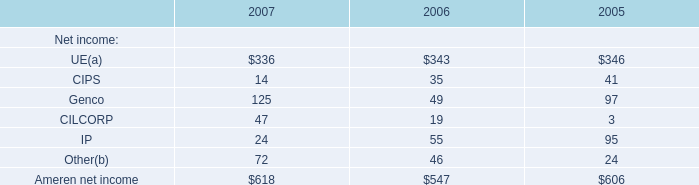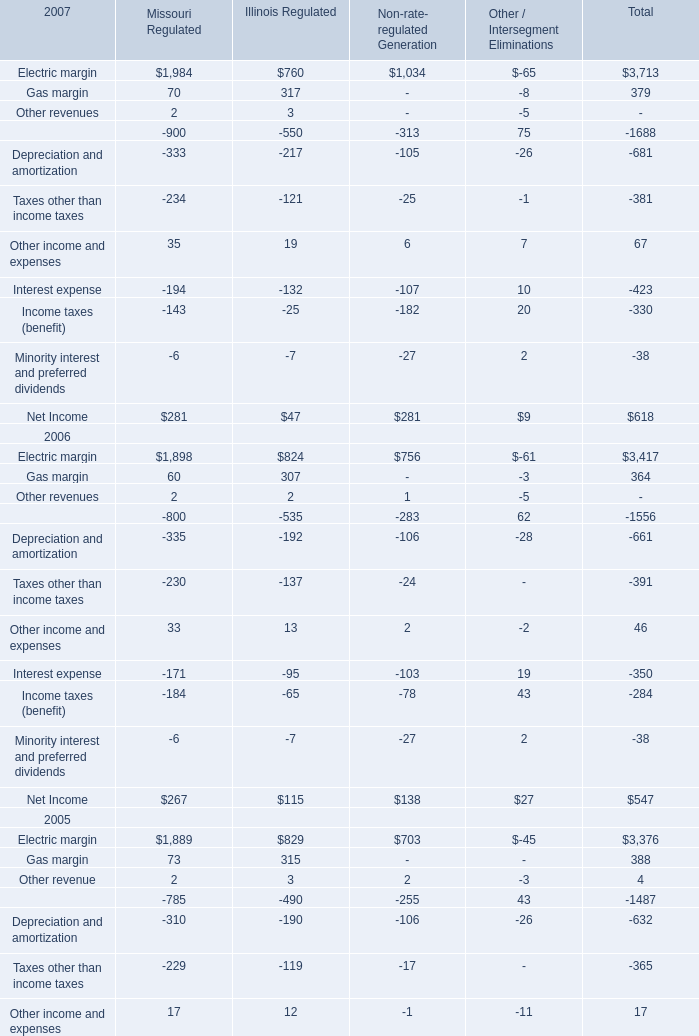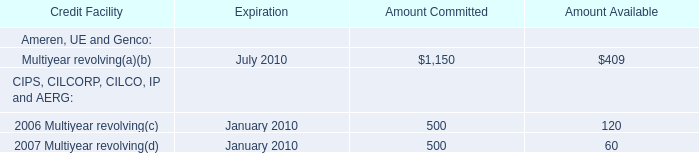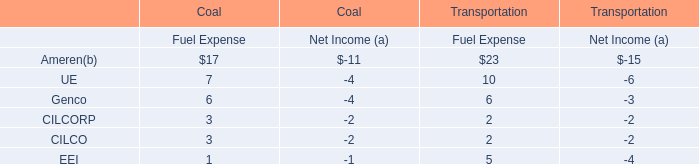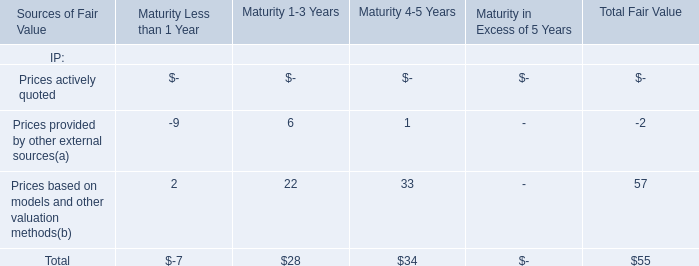Which year the Ameren net income is the highest? 
Answer: 2007. 